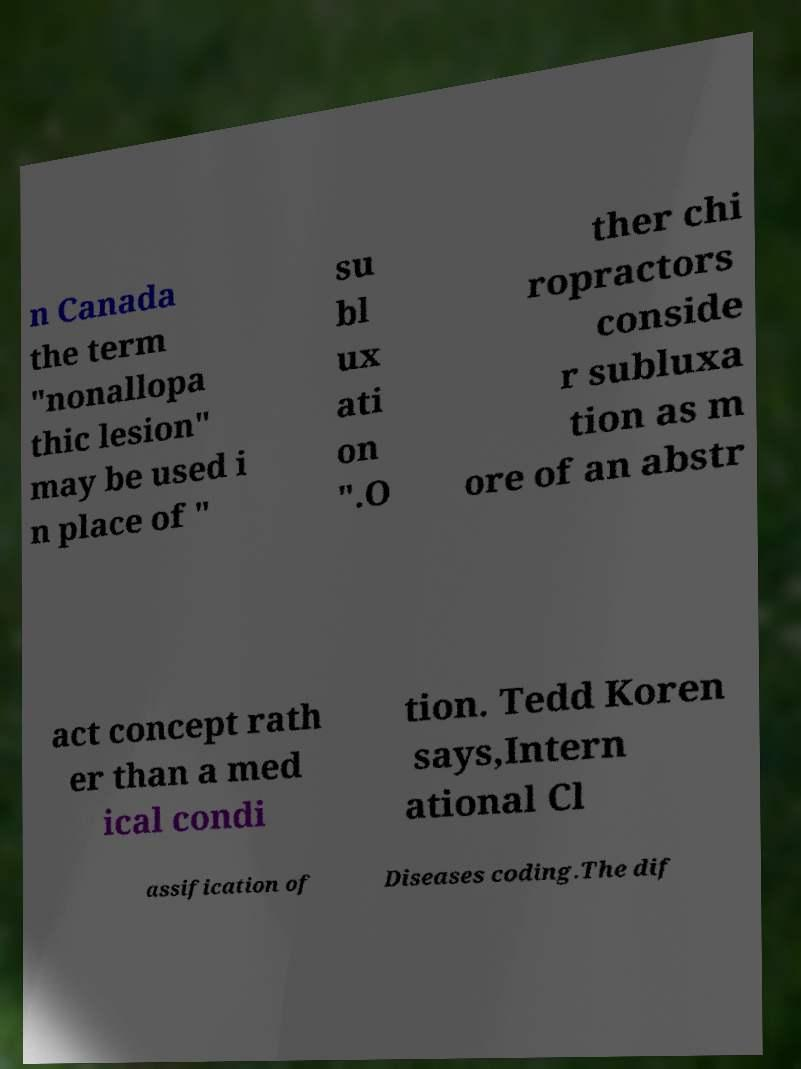Could you assist in decoding the text presented in this image and type it out clearly? n Canada the term "nonallopa thic lesion" may be used i n place of " su bl ux ati on ".O ther chi ropractors conside r subluxa tion as m ore of an abstr act concept rath er than a med ical condi tion. Tedd Koren says,Intern ational Cl assification of Diseases coding.The dif 